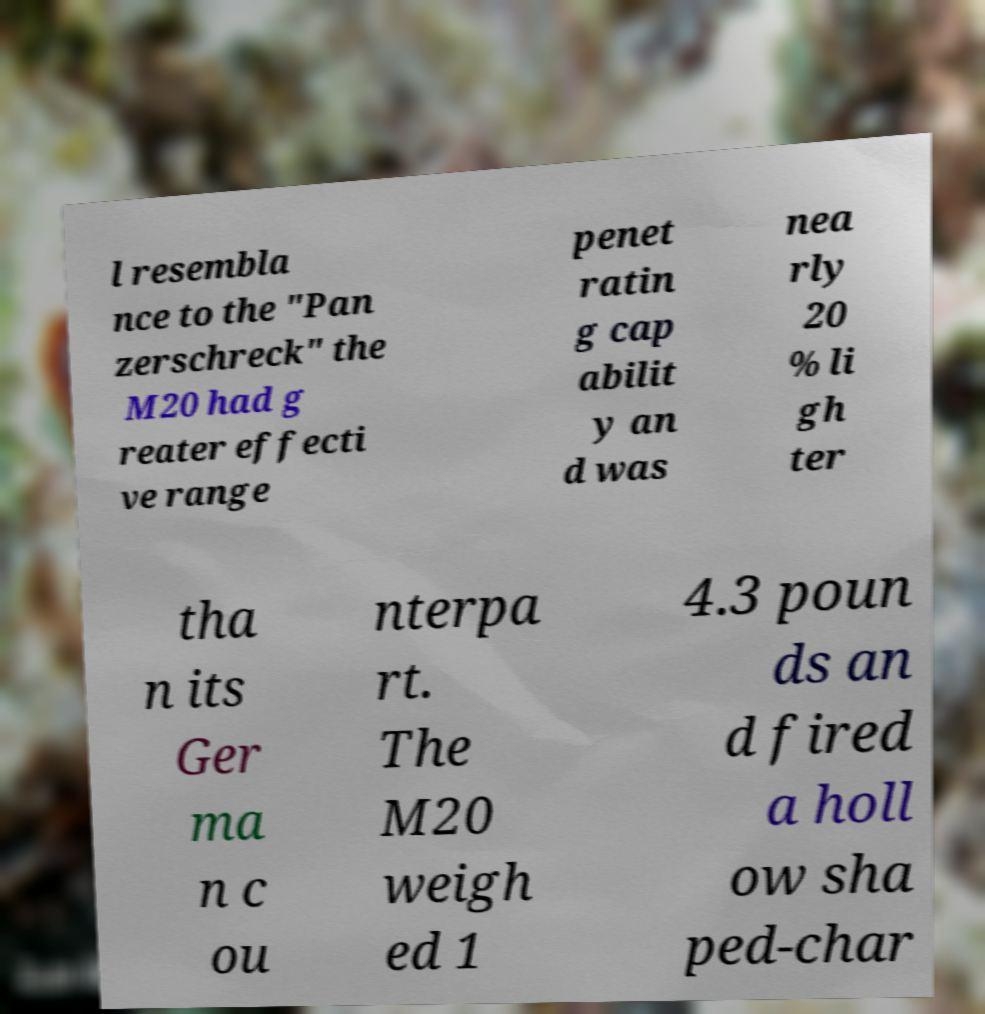I need the written content from this picture converted into text. Can you do that? l resembla nce to the "Pan zerschreck" the M20 had g reater effecti ve range penet ratin g cap abilit y an d was nea rly 20 % li gh ter tha n its Ger ma n c ou nterpa rt. The M20 weigh ed 1 4.3 poun ds an d fired a holl ow sha ped-char 